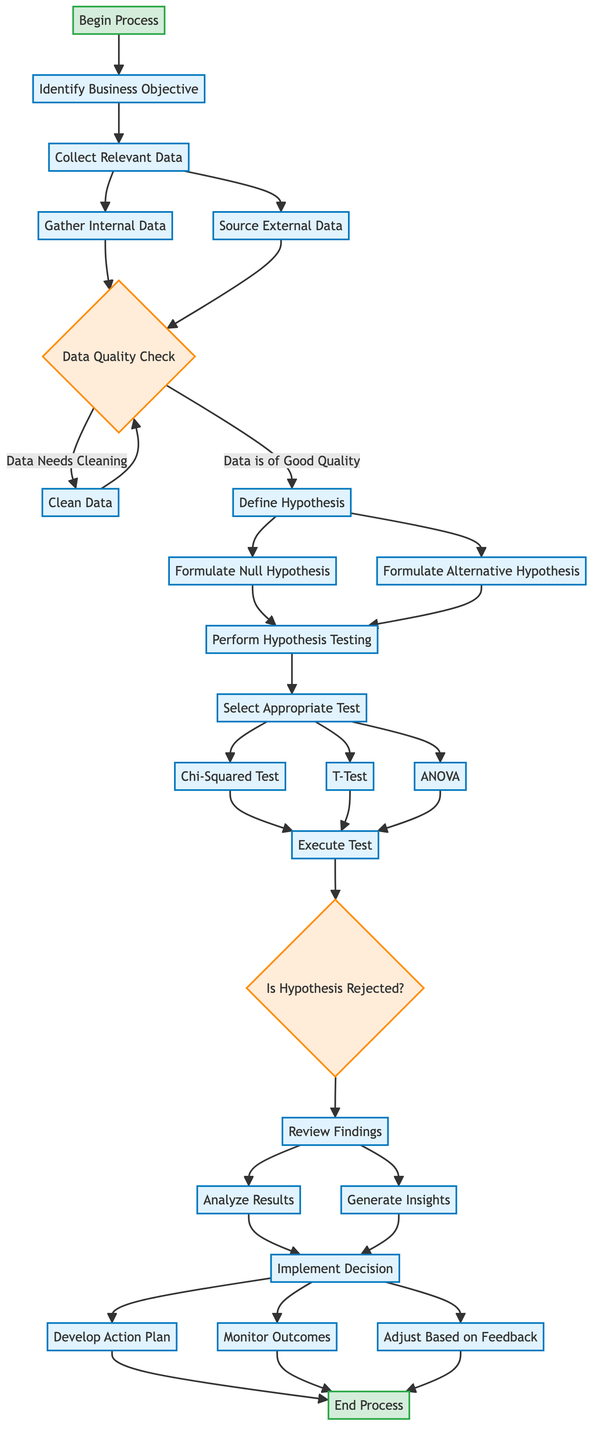What is the first step in the process? The first step in the flow chart is labeled "Begin Process," which indicates the initiation of the framework for making data-driven decisions.
Answer: Begin Process How many decisions are present in the diagram? The diagram contains two instances of a decision node: "Data Quality Check" and "Is Hypothesis Rejected?" which means there are a total of two decision points.
Answer: 2 What follows after "Define Hypothesis"? After "Define Hypothesis," the next node in the flow chart is "Perform Hypothesis Testing," which means that defining the hypothesis leads to hypothesis testing.
Answer: Perform Hypothesis Testing What happens if the data is of good quality? If the data is of good quality, the next step is "Define Hypothesis," which indicates that quality data leads directly to hypothesis definition.
Answer: Define Hypothesis What specific tests can be selected during "Perform Hypothesis Testing"? During "Perform Hypothesis Testing," the specific tests that can be selected are "Chi-Squared Test," "T-Test," and "ANOVA," which outlines the testing options available during this stage.
Answer: Chi-Squared Test, T-Test, ANOVA What are the final steps taken after reviewing findings? After reviewing findings, the framework directs to "Implement Decision," which is then followed by three more actions: "Develop Action Plan," "Monitor Outcomes," and "Adjust Based on Feedback."
Answer: Implement Decision What does the process conclude with? The process concludes with the node labeled "End Process," which signifies the conclusion of the entire decision-making framework.
Answer: End Process When does the process revert to cleaning data? The process reverts to cleaning data when the "Data Quality Check" indicates that "Data Needs Cleaning," meaning low-quality data requires cleaning before proceeding.
Answer: Clean Data How many processes are there in total? The diagram consists of several processes including "Identify Business Objective," "Collect Relevant Data," "Define Hypothesis," "Perform Hypothesis Testing," "Review Findings," and "Implement Decision," leading to a total of six distinct processes.
Answer: 6 